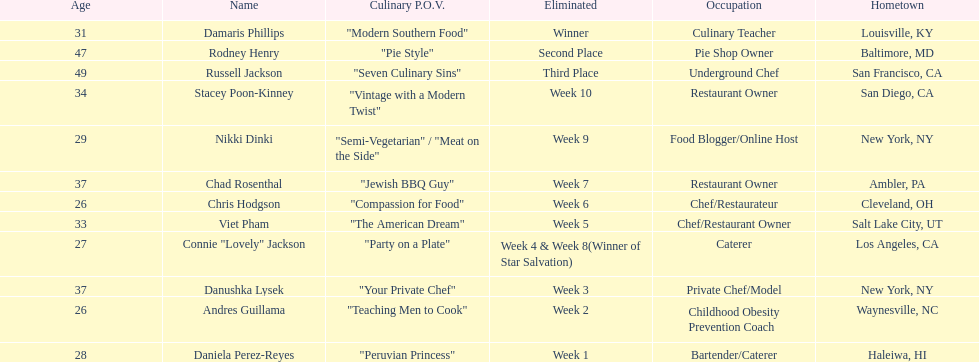Which contestant's culinary point of view had a longer description than "vintage with a modern twist"? Nikki Dinki. 